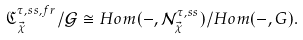<formula> <loc_0><loc_0><loc_500><loc_500>\mathfrak { C } _ { \vec { \chi } } ^ { \tau , s s , f r } / \mathcal { G } \cong H o m ( - , \mathcal { N } _ { \vec { \chi } } ^ { \tau , s s } ) / H o m ( - , G ) .</formula> 